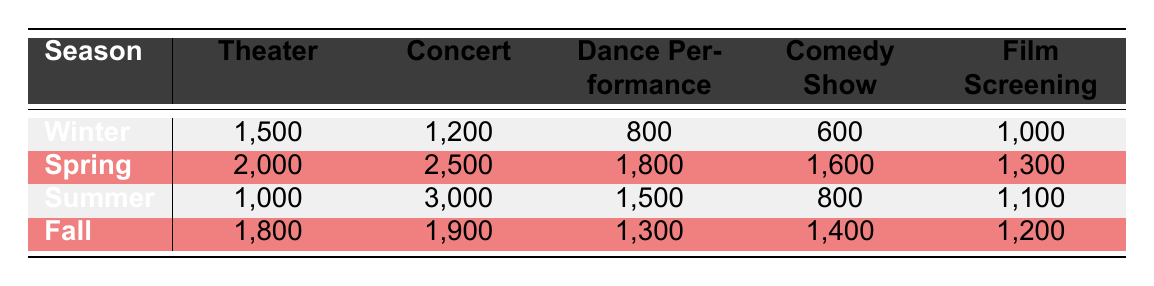What is the highest attendance for any event type in Spring? In Spring, the attendances for each event type are: Theater (2000), Concert (2500), Dance Performance (1800), Comedy Show (1600), and Film Screening (1300). The Concert has the highest attendance of 2500.
Answer: 2500 Which event type had the lowest attendance in Winter? In Winter, the attendances for event types are: Theater (1500), Concert (1200), Dance Performance (800), Comedy Show (600), and Film Screening (1000). The Comedy Show has the lowest attendance of 600.
Answer: 600 How many more attendees were present at Concerts in Summer compared to Winter? In Summer, the attendance for Concerts is 3000 and in Winter, it is 1200. The difference is calculated as 3000 - 1200 = 1800.
Answer: 1800 Is the attendance for Film Screenings higher in Fall than in Winter? In Fall, the attendance for Film Screenings is 1200, and in Winter, it is 1000. Since 1200 is greater than 1000, the statement is true.
Answer: Yes What is the average attendance for Dance Performances across all seasons? The attendances for Dance Performances in each season are: Winter (800), Spring (1800), Summer (1500), and Fall (1300). Summing these values gives 800 + 1800 + 1500 + 1300 = 4400. To find the average, divide by the number of seasons (4), which is 4400 / 4 = 1100.
Answer: 1100 Which season has the highest total attendance for all event types combined? To find the total attendance for each season: Winter (1500 + 1200 + 800 + 600 + 1000 = 4100), Spring (2000 + 2500 + 1800 + 1600 + 1300 = 10200), Summer (1000 + 3000 + 1500 + 800 + 1100 = 6400), Fall (1800 + 1900 + 1300 + 1400 + 1200 = 8600). The highest total is 10200 in Spring.
Answer: Spring How does the attendance for Comedy Shows in Fall compare to that in Winter? In Fall, the attendance for Comedy Shows is 1400, while in Winter, it is 600. Since 1400 is significantly greater than 600, we can conclude that attendance in Fall is higher.
Answer: Higher What is the total attendance for all event types in the Summer season? Summing the attendances for Summer yields: Theater (1000), Concert (3000), Dance Performance (1500), Comedy Show (800), and Film Screening (1100). This total is 1000 + 3000 + 1500 + 800 + 1100 = 7400.
Answer: 7400 